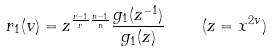Convert formula to latex. <formula><loc_0><loc_0><loc_500><loc_500>r _ { 1 } ( v ) = z ^ { \frac { r - 1 } { r } \frac { n - 1 } { n } } \frac { g _ { 1 } ( z ^ { - 1 } ) } { g _ { 1 } ( z ) } \quad ( z = x ^ { 2 v } )</formula> 